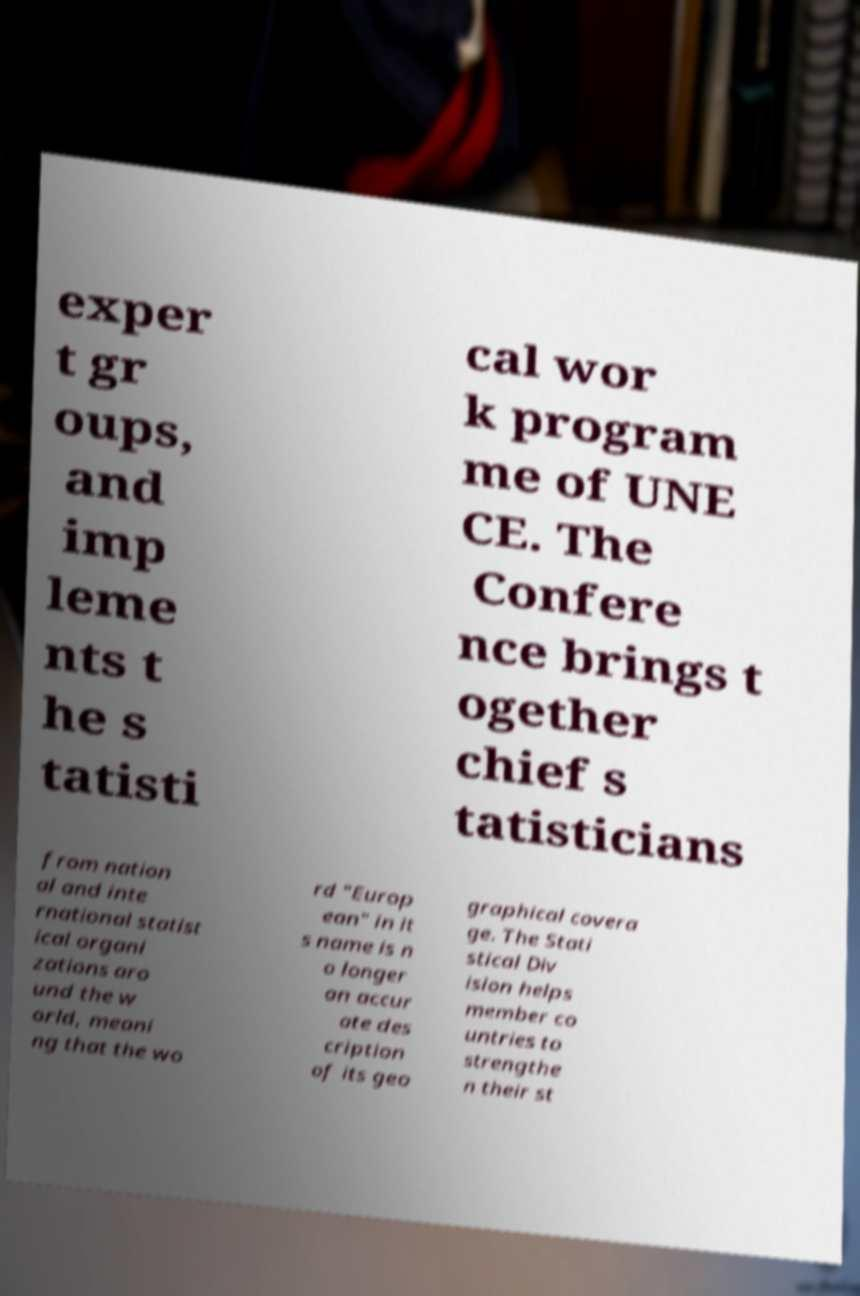Can you read and provide the text displayed in the image?This photo seems to have some interesting text. Can you extract and type it out for me? exper t gr oups, and imp leme nts t he s tatisti cal wor k program me of UNE CE. The Confere nce brings t ogether chief s tatisticians from nation al and inte rnational statist ical organi zations aro und the w orld, meani ng that the wo rd "Europ ean" in it s name is n o longer an accur ate des cription of its geo graphical covera ge. The Stati stical Div ision helps member co untries to strengthe n their st 